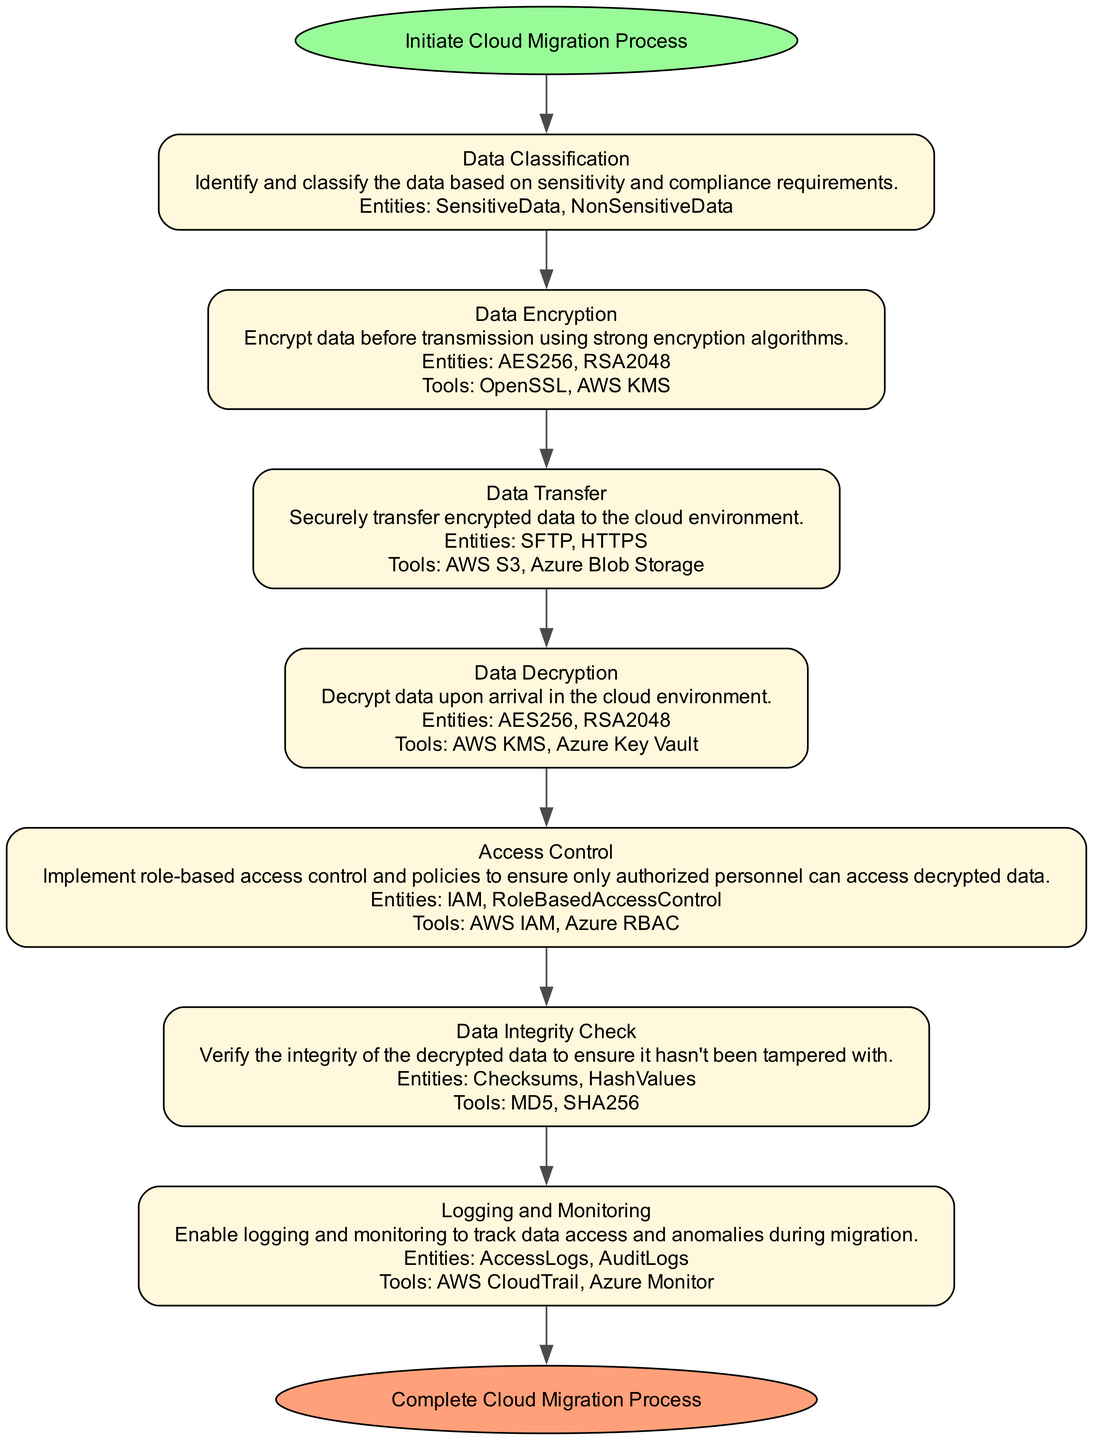What is the first step in the pipeline? The diagram indicates that the first step in the pipeline is "Data Classification," which is where data is identified and classified based on sensitivity and compliance requirements.
Answer: Data Classification How many main steps are in the pipeline? By counting the steps listed in the diagram, there are seven main steps in the data encryption and decryption pipeline.
Answer: Seven What tools are used for Data Encryption? According to the diagram, the tools used for Data Encryption are "OpenSSL" and "AWS KMS."
Answer: OpenSSL, AWS KMS Which encryption algorithms are mentioned in Data Decryption? The diagram specifies that "AES256" and "RSA2048" are the encryption algorithms mentioned in the Data Decryption step.
Answer: AES256, RSA2048 What is the last step in the pipeline? The diagram states that the last step in the pipeline is "Complete Cloud Migration Process," which signifies the end of the flow.
Answer: Complete Cloud Migration Process What is the relationship between Data Encryption and Data Transfer? The diagram shows that Data Encryption must occur before Data Transfer, indicating that encrypted data is transferred to the cloud after it has been secured.
Answer: Data Encryption precedes Data Transfer Which entities are verified during Data Integrity Check? The diagram lists "Checksums" and "HashValues" as the entities involved in the Data Integrity Check step.
Answer: Checksums, HashValues What implements the access policies after Data Decryption? After the Data Decryption step, the diagram indicates that "Role-Based Access Control" is implemented to establish access policies for decrypted data.
Answer: Role-Based Access Control How is data securely transferred according to the diagram? The diagram specifies that data is securely transferred using protocols like "SFTP" and "HTTPS."
Answer: SFTP, HTTPS 